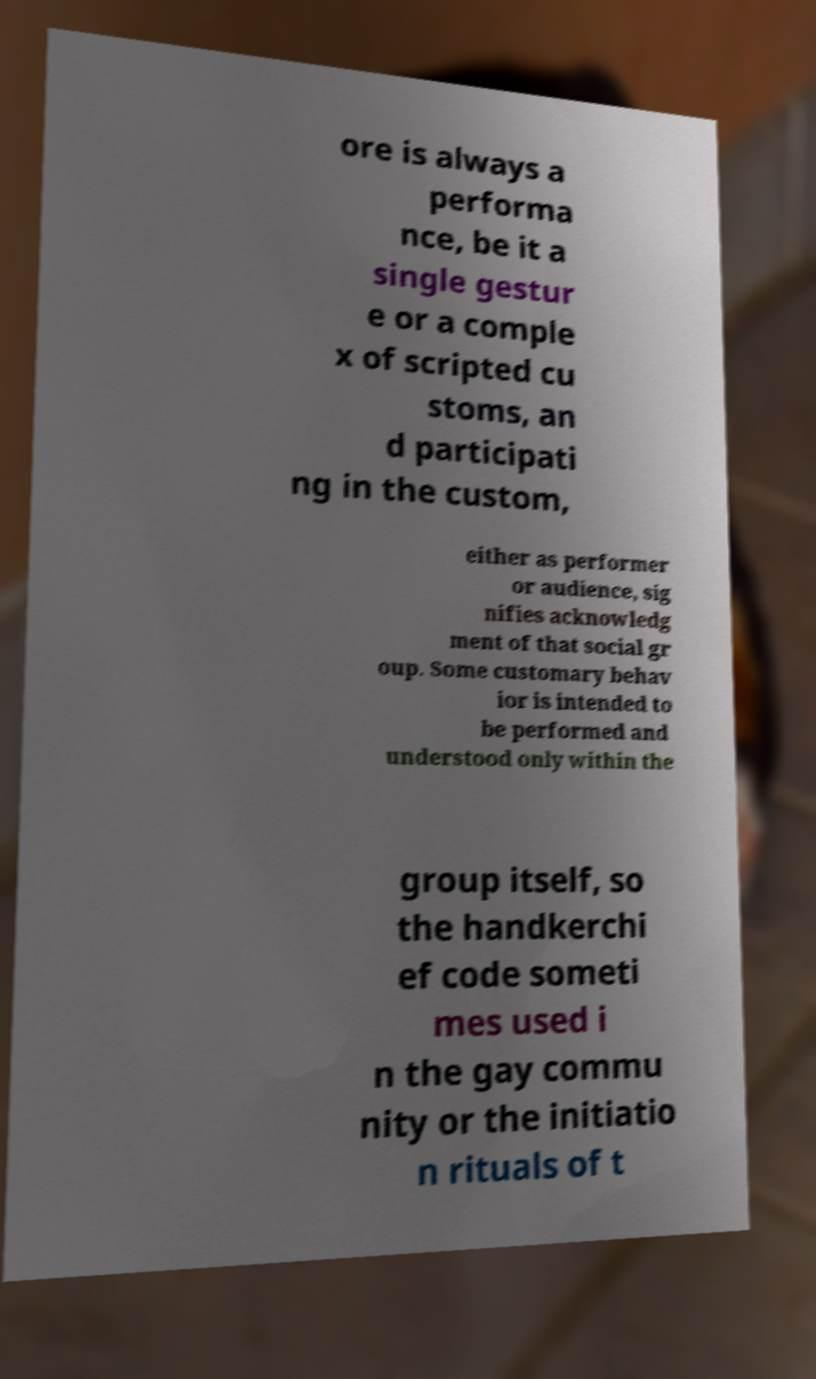Could you extract and type out the text from this image? ore is always a performa nce, be it a single gestur e or a comple x of scripted cu stoms, an d participati ng in the custom, either as performer or audience, sig nifies acknowledg ment of that social gr oup. Some customary behav ior is intended to be performed and understood only within the group itself, so the handkerchi ef code someti mes used i n the gay commu nity or the initiatio n rituals of t 